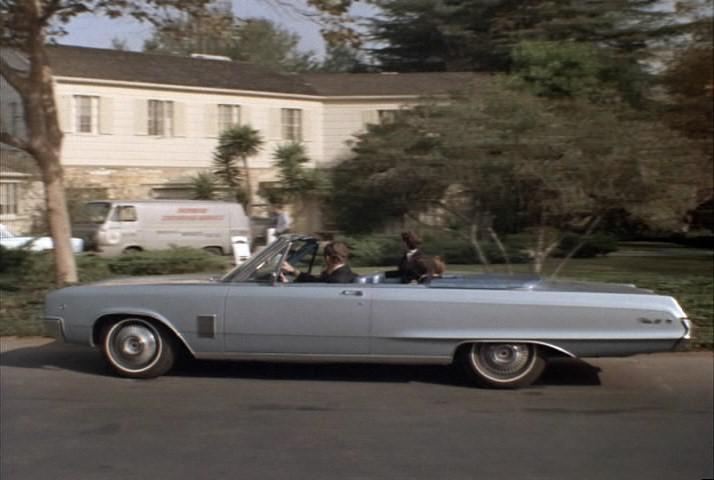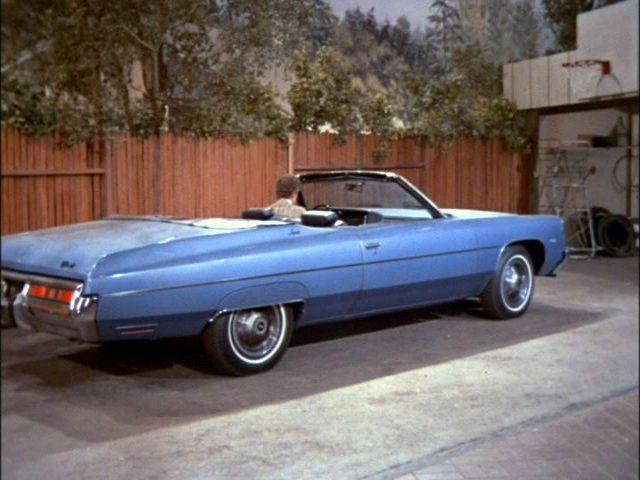The first image is the image on the left, the second image is the image on the right. Given the left and right images, does the statement "The red car on the right is sitting in the driveway." hold true? Answer yes or no. No. The first image is the image on the left, the second image is the image on the right. Evaluate the accuracy of this statement regarding the images: "Two convertibles with tops completely down are different colors and facing different directions.". Is it true? Answer yes or no. Yes. 